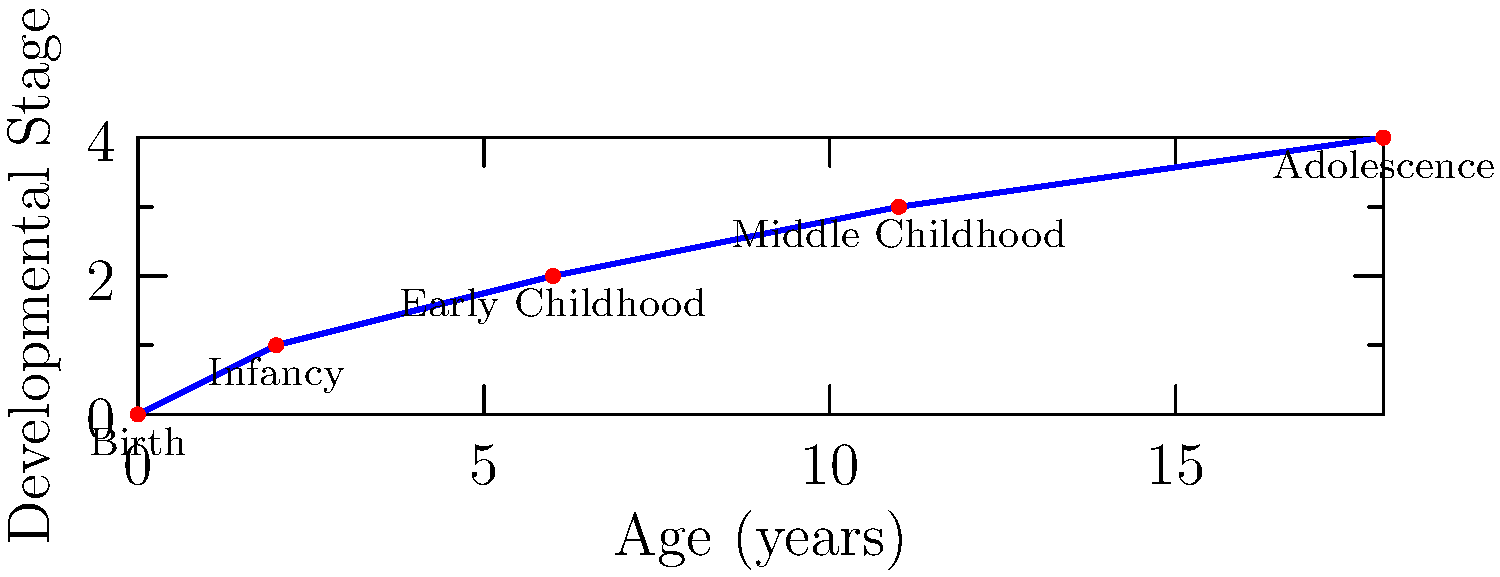Based on the diagram, which developmental stage occurs between ages 6 and 11? To answer this question, we need to analyze the diagram step-by-step:

1. The x-axis represents age in years, while the y-axis represents developmental stages.
2. The diagram shows five distinct points, each representing a different stage of childhood development.
3. We need to focus on the age range between 6 and 11 years.
4. Looking at the graph, we can see that:
   - At age 6, we are at the end of the "Early Childhood" stage.
   - At age 11, we are at the beginning of the next stage.
5. The stage that occurs between these two points is labeled "Middle Childhood".

Therefore, the developmental stage that occurs between ages 6 and 11 is Middle Childhood.
Answer: Middle Childhood 